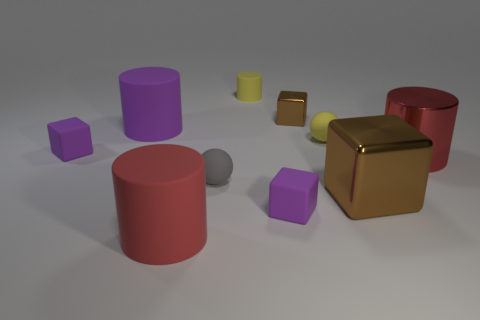There is another shiny cube that is the same color as the large metal block; what is its size?
Ensure brevity in your answer.  Small. There is a purple thing that is right of the tiny yellow matte cylinder; what material is it?
Ensure brevity in your answer.  Rubber. Are there an equal number of large red things left of the tiny brown cube and big red matte cylinders left of the large red matte object?
Provide a short and direct response. No. There is a purple object to the right of the small gray ball; does it have the same size as the brown thing in front of the red metallic cylinder?
Your answer should be compact. No. How many things have the same color as the big shiny cube?
Make the answer very short. 1. There is another thing that is the same color as the tiny shiny thing; what is it made of?
Your answer should be compact. Metal. Are there more tiny yellow rubber balls to the right of the red shiny cylinder than matte cylinders?
Your answer should be very brief. No. Is the shape of the big red matte object the same as the tiny gray matte thing?
Provide a short and direct response. No. What number of tiny yellow cylinders are the same material as the yellow sphere?
Keep it short and to the point. 1. There is another rubber thing that is the same shape as the tiny gray rubber thing; what is its size?
Your response must be concise. Small. 